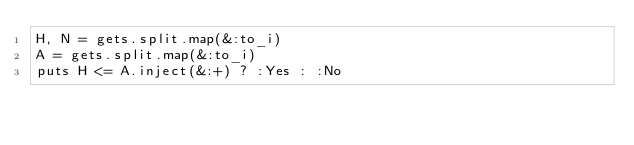Convert code to text. <code><loc_0><loc_0><loc_500><loc_500><_Ruby_>H, N = gets.split.map(&:to_i)
A = gets.split.map(&:to_i)
puts H <= A.inject(&:+) ? :Yes : :No
</code> 